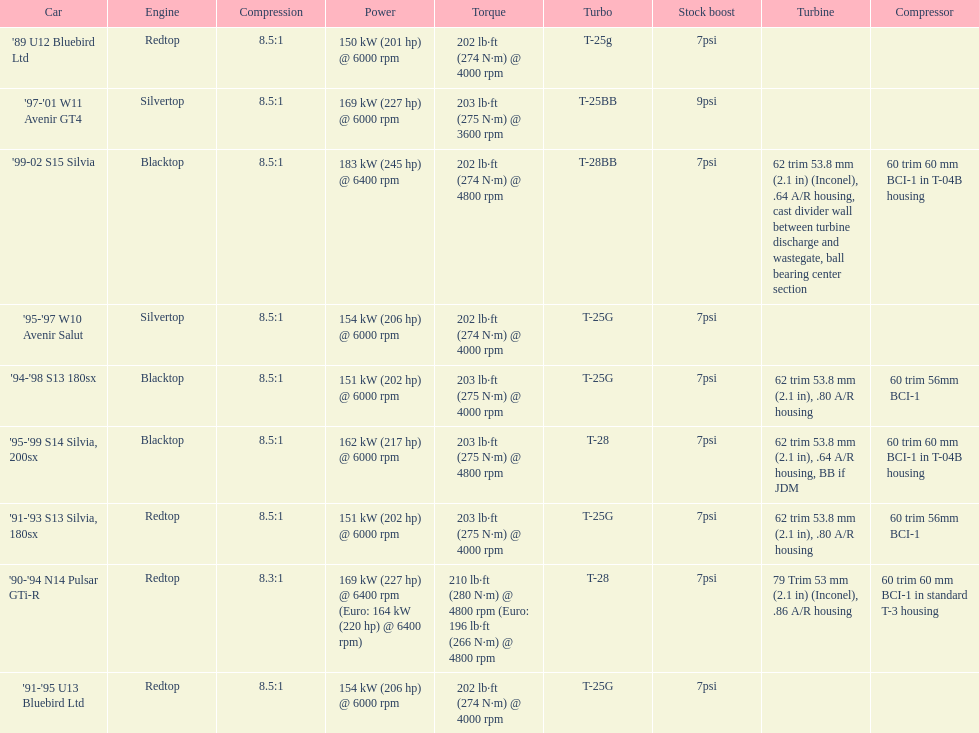How many models used the redtop engine? 4. 